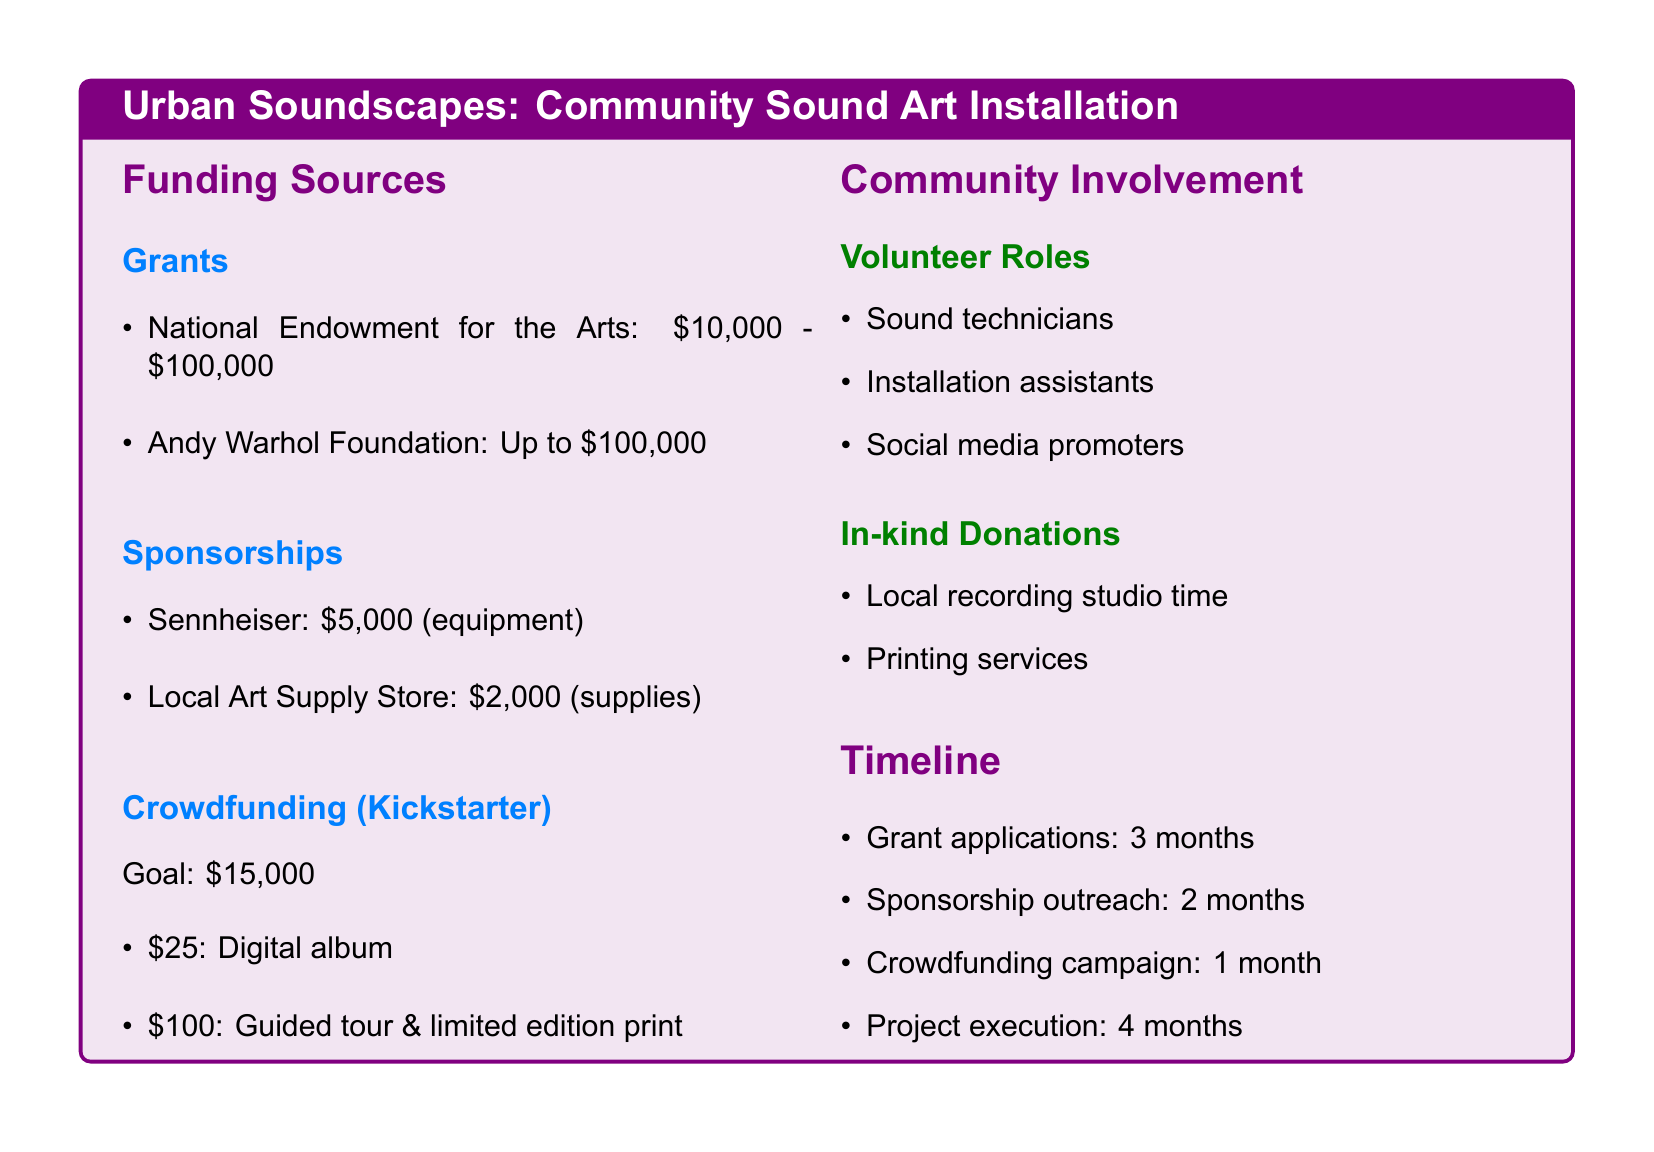What is the maximum amount available from the Andy Warhol Foundation? The maximum grant amount from the Andy Warhol Foundation is listed in the document, which states it can provide up to $100,000.
Answer: Up to $100,000 What is the goal for the crowdfunding campaign? The document specifies that the crowdfunding goal is stated clearly, which is $15,000.
Answer: $15,000 How long will the grant application take? The document outlines the timeline, indicating that the grant application process will take 3 months.
Answer: 3 months What in-kind donation comes from a local recording studio? The document mentions in-kind donations, specifically indicating that local recording studio time is one of them.
Answer: Local recording studio time Which company is providing $5,000 in sponsorship? The document indicates that Sennheiser is providing $5,000 in sponsorship for equipment.
Answer: Sennheiser What volunteer role is responsible for social media? The document lists various volunteer roles, and 'social media promoters' is mentioned as a volunteer role related to social media.
Answer: Social media promoters How many months will the project execution take? The project execution phase is specified in the document as taking 4 months.
Answer: 4 months What is one reward for a $100 crowdfunding pledge? The document specifies that a $100 pledge will get backers a guided tour and a limited edition print.
Answer: Guided tour & limited edition print 